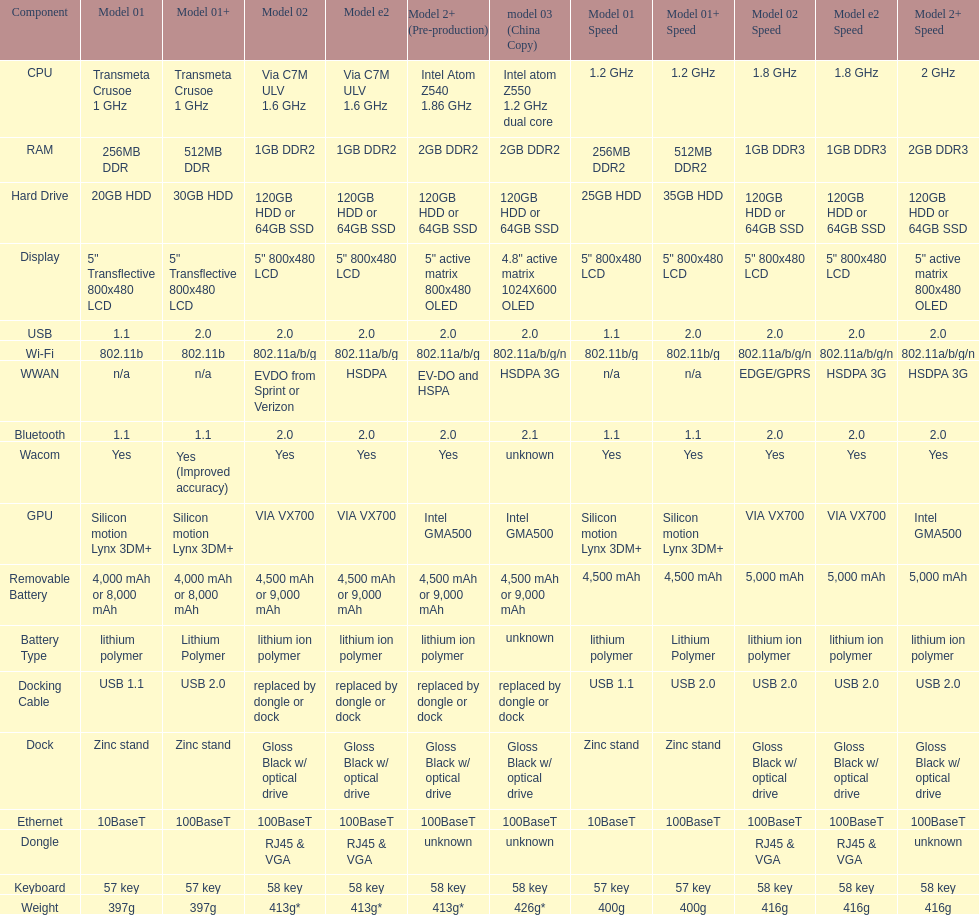What component comes after bluetooth? Wacom. 